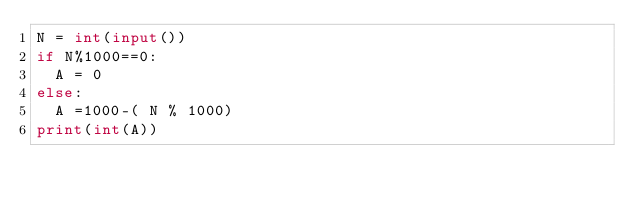Convert code to text. <code><loc_0><loc_0><loc_500><loc_500><_Python_>N = int(input())
if N%1000==0:
  A = 0
else:
  A =1000-( N % 1000)
print(int(A))</code> 